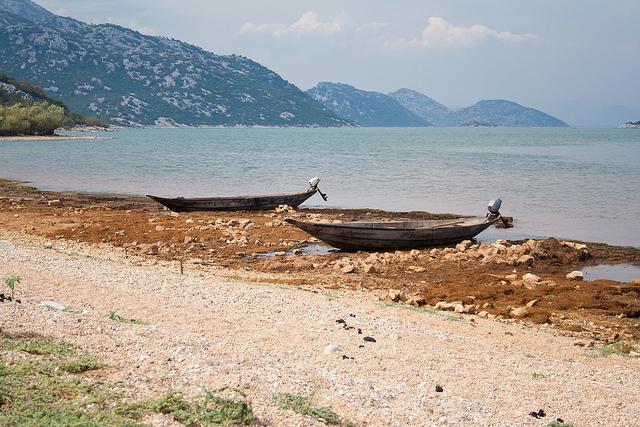Is this  a beach?
Be succinct. Yes. How many boats are in the photo?
Quick response, please. 2. Are there any people in the boats?
Keep it brief. No. How many boats are about to get in the water?
Write a very short answer. 2. 